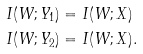Convert formula to latex. <formula><loc_0><loc_0><loc_500><loc_500>I ( W ; Y _ { 1 } ) & = I ( W ; X ) \\ I ( W ; Y _ { 2 } ) & = I ( W ; X ) .</formula> 